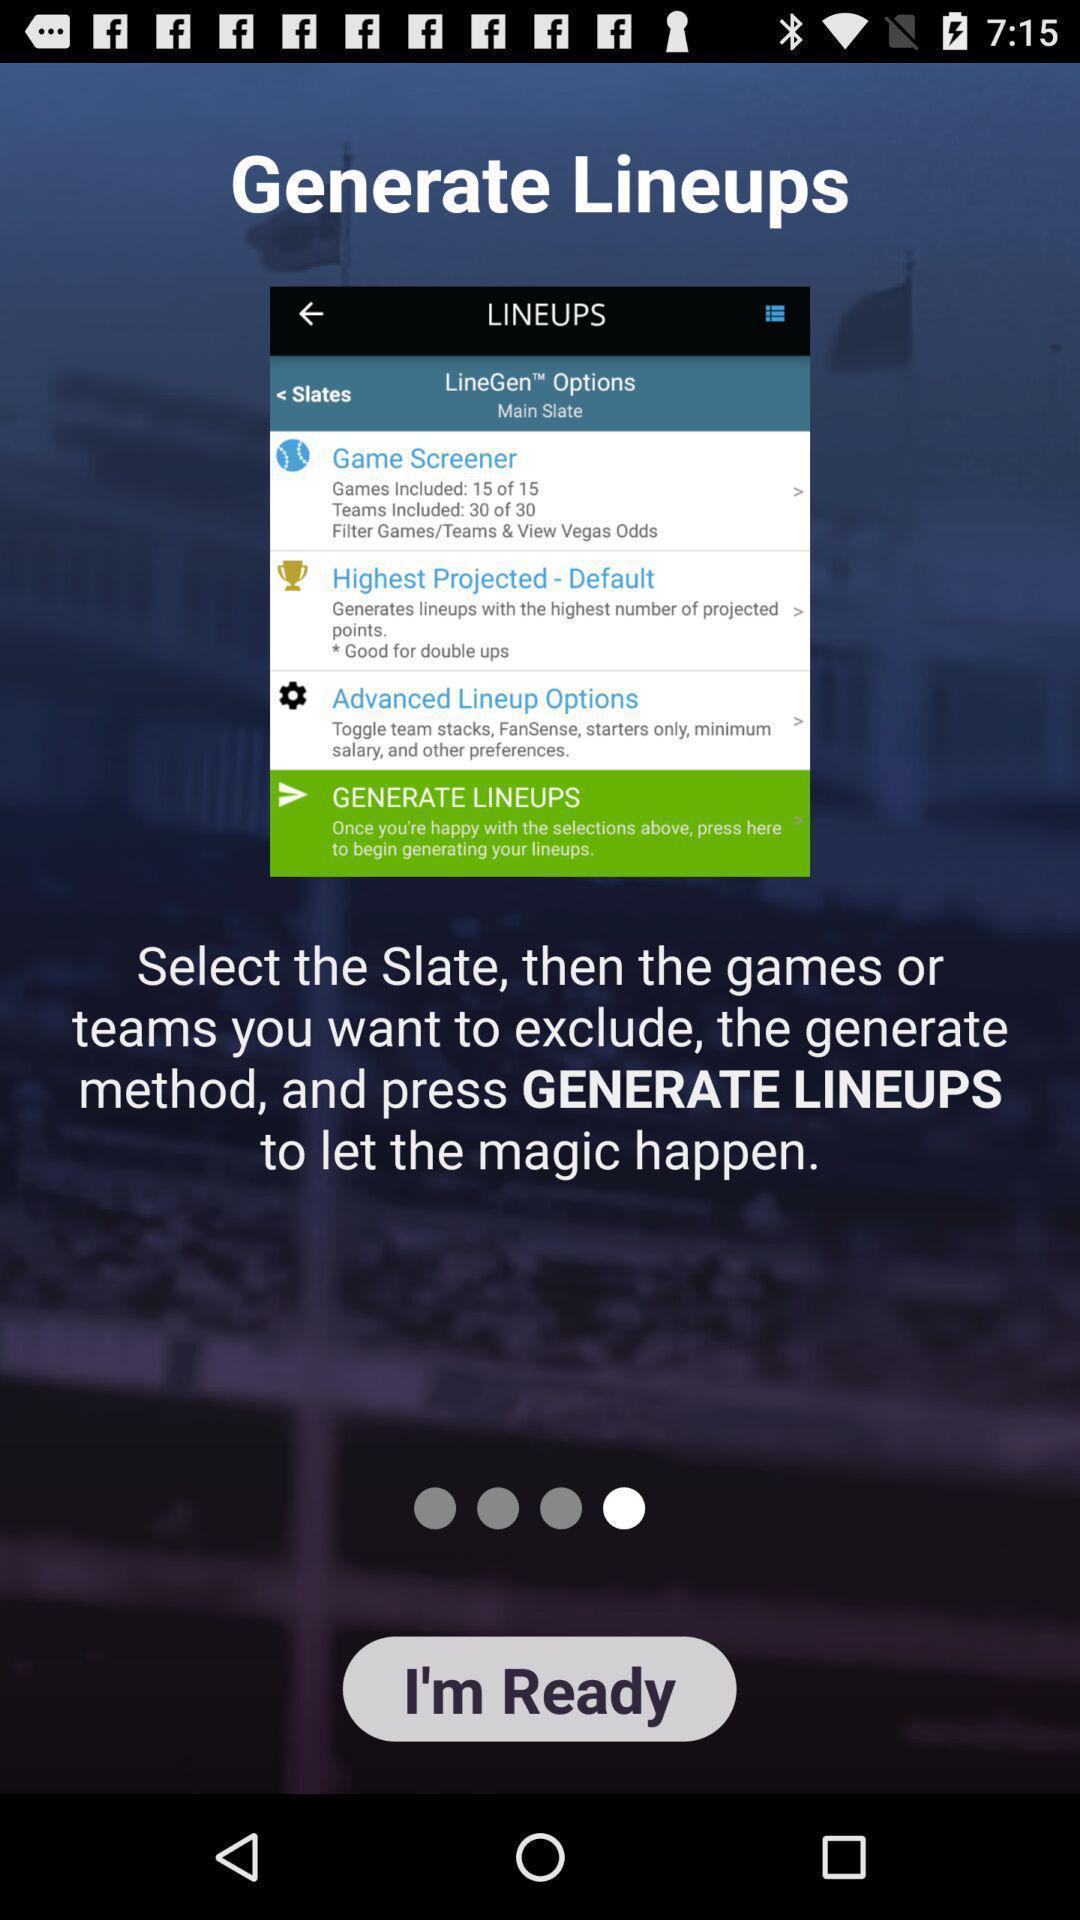Explain the elements present in this screenshot. Screen shows generate lineups. 